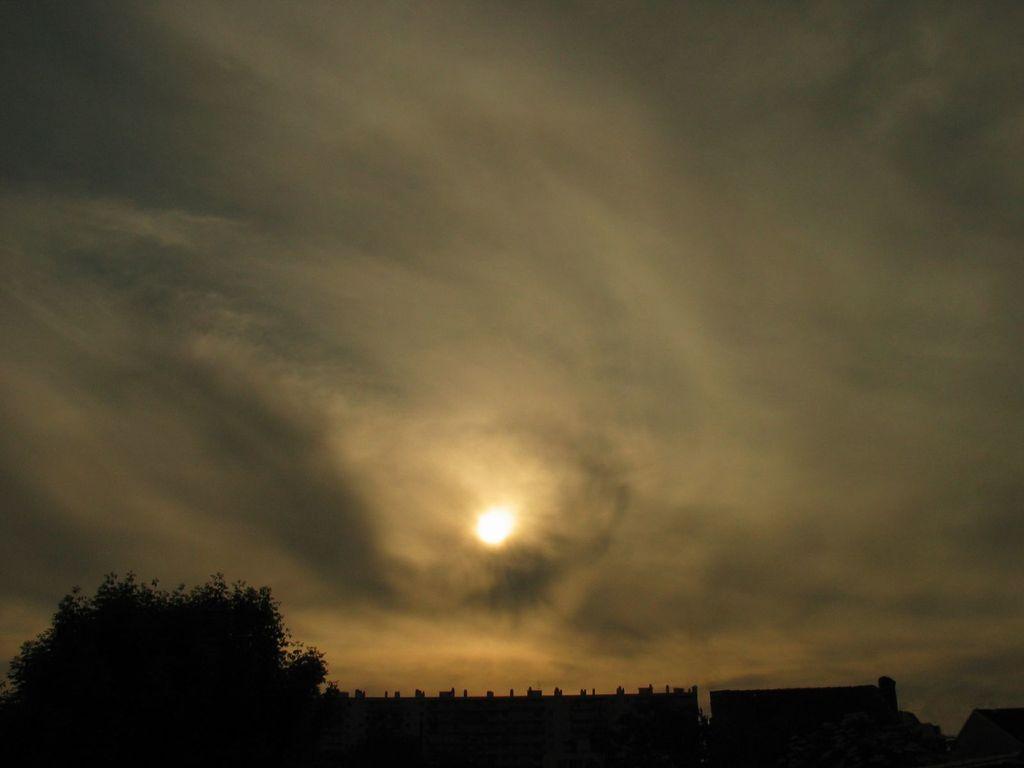Describe this image in one or two sentences. This is the picture of the sun in the sky and clouds. There is a tree and a few buildings in the bottom of the image. 